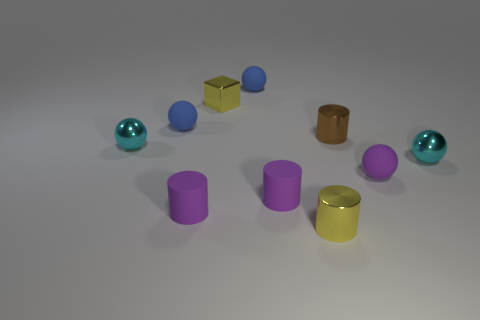Are there any metal spheres of the same size as the brown metallic cylinder?
Your response must be concise. Yes. There is a blue rubber thing that is to the right of the small purple cylinder on the left side of the shiny block; what is its size?
Your answer should be very brief. Small. How many tiny metallic cylinders have the same color as the shiny block?
Offer a terse response. 1. What shape is the small yellow shiny thing in front of the small yellow object that is behind the small brown shiny cylinder?
Your answer should be compact. Cylinder. How many tiny blue balls have the same material as the cube?
Provide a succinct answer. 0. What material is the small purple ball in front of the small brown cylinder?
Offer a very short reply. Rubber. There is a cyan thing to the left of the small metal cylinder in front of the metal object to the right of the small brown cylinder; what is its shape?
Keep it short and to the point. Sphere. There is a small metallic ball to the right of the yellow cylinder; is it the same color as the tiny shiny sphere to the left of the brown shiny thing?
Keep it short and to the point. Yes. Is the number of matte things behind the yellow metal block less than the number of blue matte things right of the yellow cylinder?
Give a very brief answer. No. There is another small shiny thing that is the same shape as the brown metallic thing; what is its color?
Make the answer very short. Yellow. 